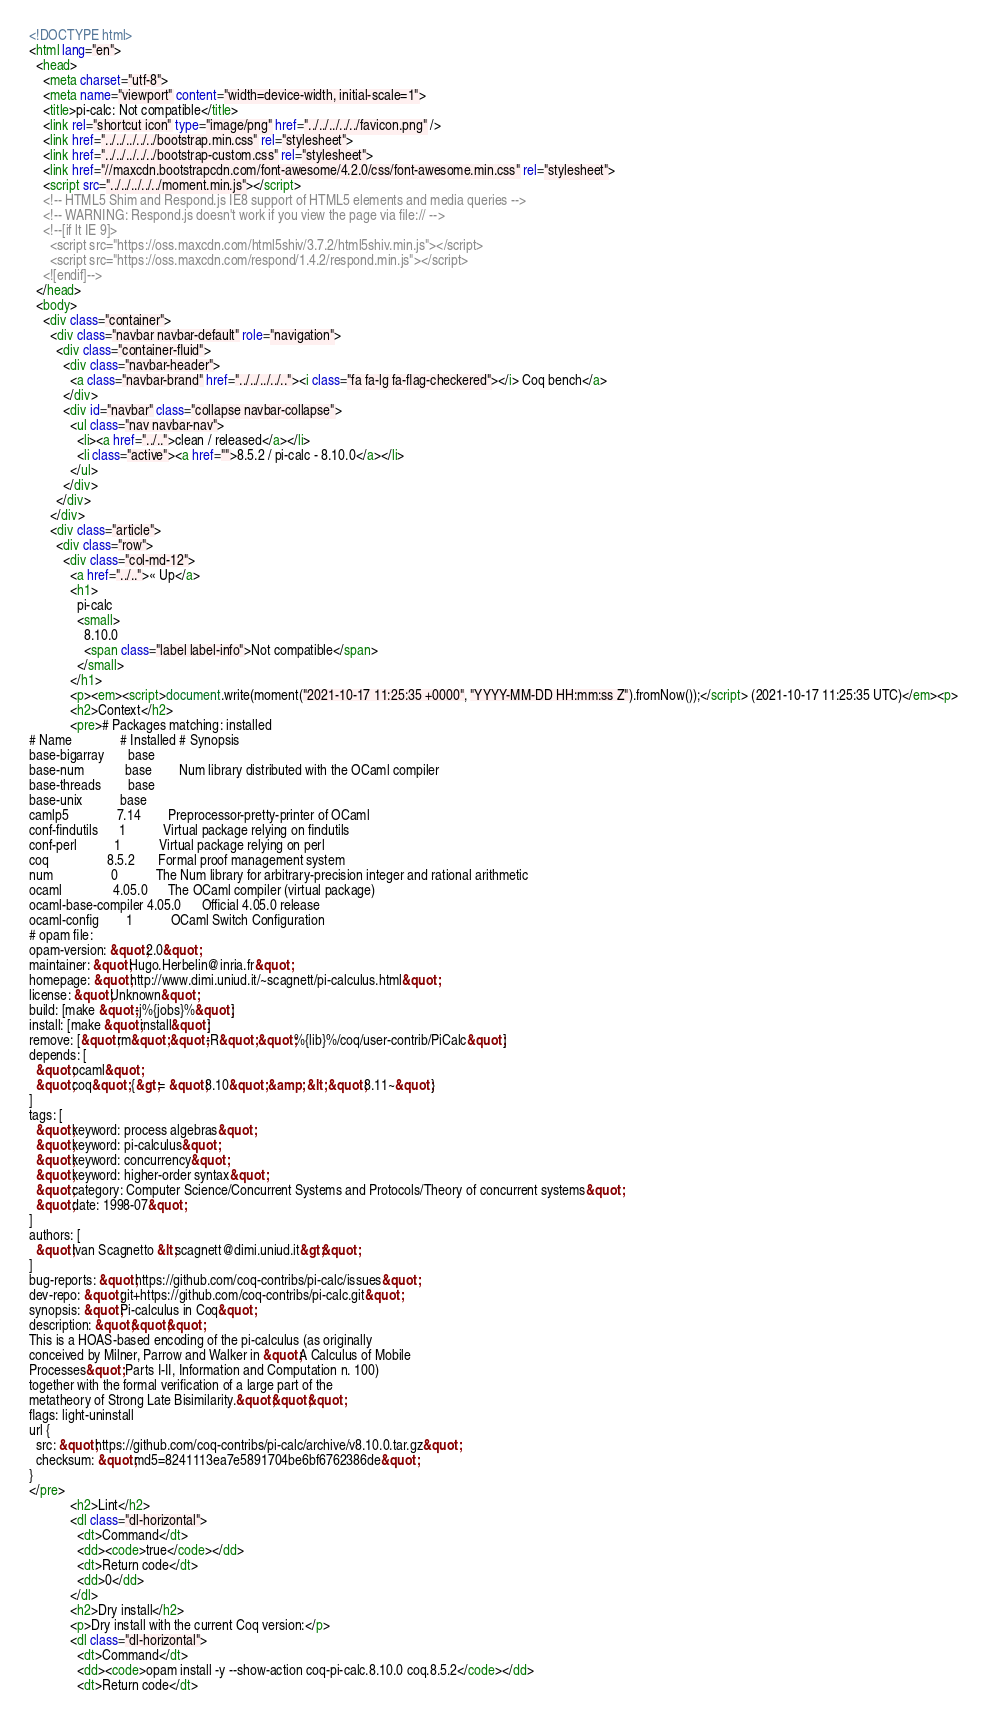Convert code to text. <code><loc_0><loc_0><loc_500><loc_500><_HTML_><!DOCTYPE html>
<html lang="en">
  <head>
    <meta charset="utf-8">
    <meta name="viewport" content="width=device-width, initial-scale=1">
    <title>pi-calc: Not compatible</title>
    <link rel="shortcut icon" type="image/png" href="../../../../../favicon.png" />
    <link href="../../../../../bootstrap.min.css" rel="stylesheet">
    <link href="../../../../../bootstrap-custom.css" rel="stylesheet">
    <link href="//maxcdn.bootstrapcdn.com/font-awesome/4.2.0/css/font-awesome.min.css" rel="stylesheet">
    <script src="../../../../../moment.min.js"></script>
    <!-- HTML5 Shim and Respond.js IE8 support of HTML5 elements and media queries -->
    <!-- WARNING: Respond.js doesn't work if you view the page via file:// -->
    <!--[if lt IE 9]>
      <script src="https://oss.maxcdn.com/html5shiv/3.7.2/html5shiv.min.js"></script>
      <script src="https://oss.maxcdn.com/respond/1.4.2/respond.min.js"></script>
    <![endif]-->
  </head>
  <body>
    <div class="container">
      <div class="navbar navbar-default" role="navigation">
        <div class="container-fluid">
          <div class="navbar-header">
            <a class="navbar-brand" href="../../../../.."><i class="fa fa-lg fa-flag-checkered"></i> Coq bench</a>
          </div>
          <div id="navbar" class="collapse navbar-collapse">
            <ul class="nav navbar-nav">
              <li><a href="../..">clean / released</a></li>
              <li class="active"><a href="">8.5.2 / pi-calc - 8.10.0</a></li>
            </ul>
          </div>
        </div>
      </div>
      <div class="article">
        <div class="row">
          <div class="col-md-12">
            <a href="../..">« Up</a>
            <h1>
              pi-calc
              <small>
                8.10.0
                <span class="label label-info">Not compatible</span>
              </small>
            </h1>
            <p><em><script>document.write(moment("2021-10-17 11:25:35 +0000", "YYYY-MM-DD HH:mm:ss Z").fromNow());</script> (2021-10-17 11:25:35 UTC)</em><p>
            <h2>Context</h2>
            <pre># Packages matching: installed
# Name              # Installed # Synopsis
base-bigarray       base
base-num            base        Num library distributed with the OCaml compiler
base-threads        base
base-unix           base
camlp5              7.14        Preprocessor-pretty-printer of OCaml
conf-findutils      1           Virtual package relying on findutils
conf-perl           1           Virtual package relying on perl
coq                 8.5.2       Formal proof management system
num                 0           The Num library for arbitrary-precision integer and rational arithmetic
ocaml               4.05.0      The OCaml compiler (virtual package)
ocaml-base-compiler 4.05.0      Official 4.05.0 release
ocaml-config        1           OCaml Switch Configuration
# opam file:
opam-version: &quot;2.0&quot;
maintainer: &quot;Hugo.Herbelin@inria.fr&quot;
homepage: &quot;http://www.dimi.uniud.it/~scagnett/pi-calculus.html&quot;
license: &quot;Unknown&quot;
build: [make &quot;-j%{jobs}%&quot;]
install: [make &quot;install&quot;]
remove: [&quot;rm&quot; &quot;-R&quot; &quot;%{lib}%/coq/user-contrib/PiCalc&quot;]
depends: [
  &quot;ocaml&quot;
  &quot;coq&quot; {&gt;= &quot;8.10&quot; &amp; &lt; &quot;8.11~&quot;}
]
tags: [
  &quot;keyword: process algebras&quot;
  &quot;keyword: pi-calculus&quot;
  &quot;keyword: concurrency&quot;
  &quot;keyword: higher-order syntax&quot;
  &quot;category: Computer Science/Concurrent Systems and Protocols/Theory of concurrent systems&quot;
  &quot;date: 1998-07&quot;
]
authors: [
  &quot;Ivan Scagnetto &lt;scagnett@dimi.uniud.it&gt;&quot;
]
bug-reports: &quot;https://github.com/coq-contribs/pi-calc/issues&quot;
dev-repo: &quot;git+https://github.com/coq-contribs/pi-calc.git&quot;
synopsis: &quot;Pi-calculus in Coq&quot;
description: &quot;&quot;&quot;
This is a HOAS-based encoding of the pi-calculus (as originally
conceived by Milner, Parrow and Walker in &quot;A Calculus of Mobile
Processes&quot; Parts I-II, Information and Computation n. 100)
together with the formal verification of a large part of the
metatheory of Strong Late Bisimilarity.&quot;&quot;&quot;
flags: light-uninstall
url {
  src: &quot;https://github.com/coq-contribs/pi-calc/archive/v8.10.0.tar.gz&quot;
  checksum: &quot;md5=8241113ea7e5891704be6bf6762386de&quot;
}
</pre>
            <h2>Lint</h2>
            <dl class="dl-horizontal">
              <dt>Command</dt>
              <dd><code>true</code></dd>
              <dt>Return code</dt>
              <dd>0</dd>
            </dl>
            <h2>Dry install</h2>
            <p>Dry install with the current Coq version:</p>
            <dl class="dl-horizontal">
              <dt>Command</dt>
              <dd><code>opam install -y --show-action coq-pi-calc.8.10.0 coq.8.5.2</code></dd>
              <dt>Return code</dt></code> 